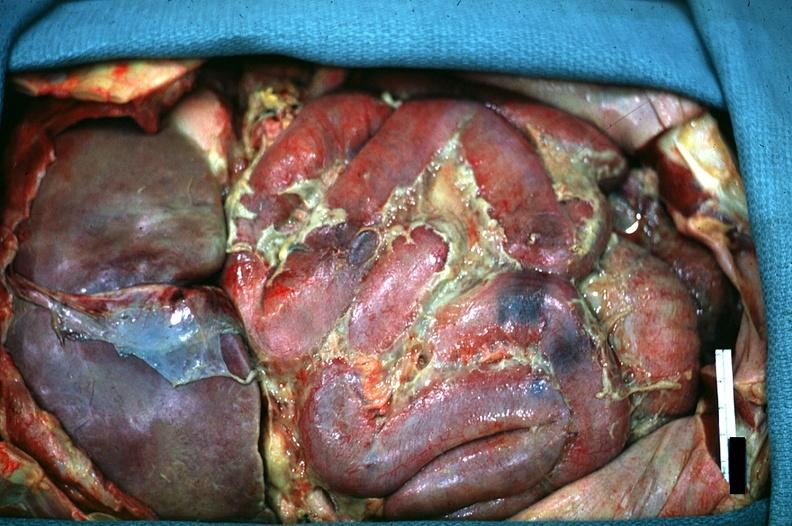what is present?
Answer the question using a single word or phrase. Acute peritonitis 